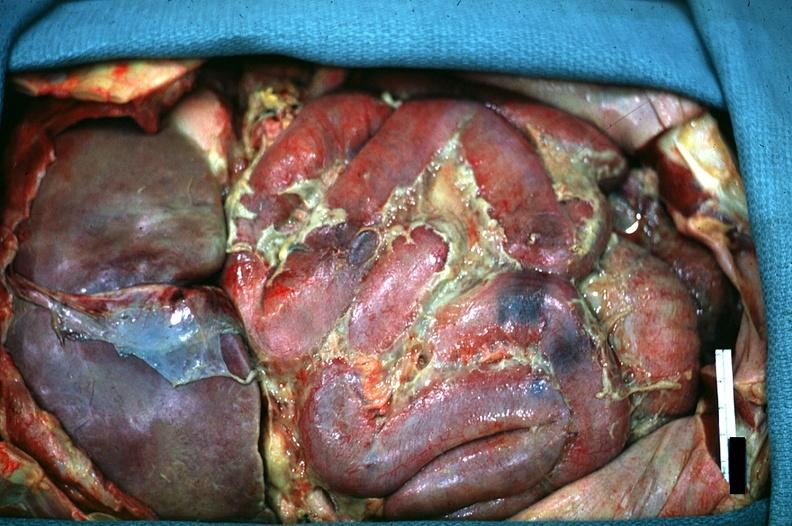what is present?
Answer the question using a single word or phrase. Acute peritonitis 